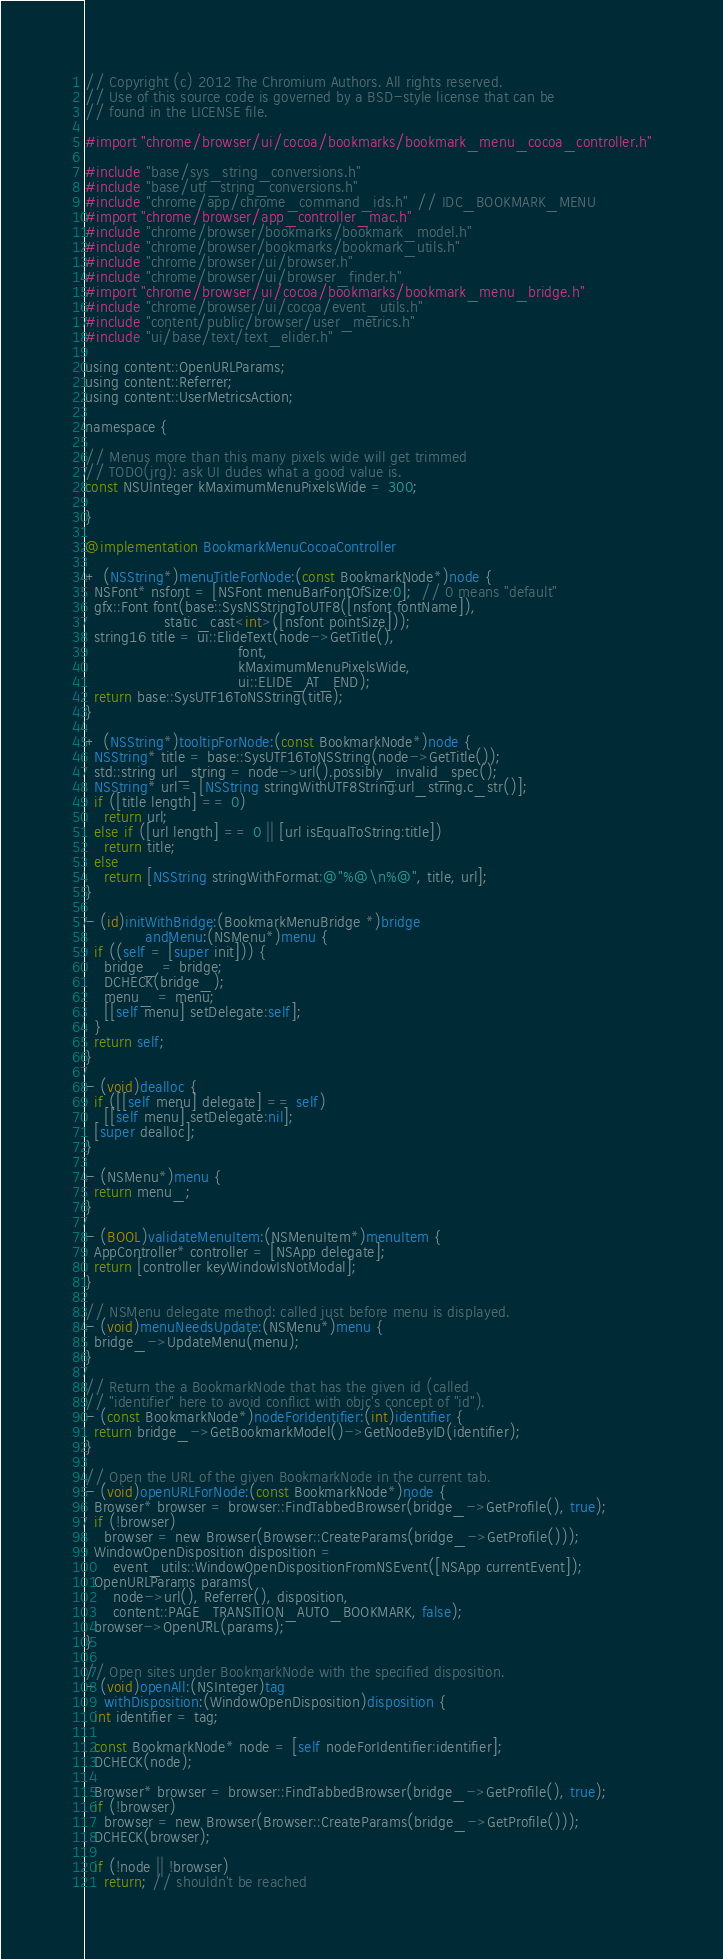<code> <loc_0><loc_0><loc_500><loc_500><_ObjectiveC_>// Copyright (c) 2012 The Chromium Authors. All rights reserved.
// Use of this source code is governed by a BSD-style license that can be
// found in the LICENSE file.

#import "chrome/browser/ui/cocoa/bookmarks/bookmark_menu_cocoa_controller.h"

#include "base/sys_string_conversions.h"
#include "base/utf_string_conversions.h"
#include "chrome/app/chrome_command_ids.h"  // IDC_BOOKMARK_MENU
#import "chrome/browser/app_controller_mac.h"
#include "chrome/browser/bookmarks/bookmark_model.h"
#include "chrome/browser/bookmarks/bookmark_utils.h"
#include "chrome/browser/ui/browser.h"
#include "chrome/browser/ui/browser_finder.h"
#import "chrome/browser/ui/cocoa/bookmarks/bookmark_menu_bridge.h"
#include "chrome/browser/ui/cocoa/event_utils.h"
#include "content/public/browser/user_metrics.h"
#include "ui/base/text/text_elider.h"

using content::OpenURLParams;
using content::Referrer;
using content::UserMetricsAction;

namespace {

// Menus more than this many pixels wide will get trimmed
// TODO(jrg): ask UI dudes what a good value is.
const NSUInteger kMaximumMenuPixelsWide = 300;

}

@implementation BookmarkMenuCocoaController

+ (NSString*)menuTitleForNode:(const BookmarkNode*)node {
  NSFont* nsfont = [NSFont menuBarFontOfSize:0];  // 0 means "default"
  gfx::Font font(base::SysNSStringToUTF8([nsfont fontName]),
                 static_cast<int>([nsfont pointSize]));
  string16 title = ui::ElideText(node->GetTitle(),
                                 font,
                                 kMaximumMenuPixelsWide,
                                 ui::ELIDE_AT_END);
  return base::SysUTF16ToNSString(title);
}

+ (NSString*)tooltipForNode:(const BookmarkNode*)node {
  NSString* title = base::SysUTF16ToNSString(node->GetTitle());
  std::string url_string = node->url().possibly_invalid_spec();
  NSString* url = [NSString stringWithUTF8String:url_string.c_str()];
  if ([title length] == 0)
    return url;
  else if ([url length] == 0 || [url isEqualToString:title])
    return title;
  else
    return [NSString stringWithFormat:@"%@\n%@", title, url];
}

- (id)initWithBridge:(BookmarkMenuBridge *)bridge
             andMenu:(NSMenu*)menu {
  if ((self = [super init])) {
    bridge_ = bridge;
    DCHECK(bridge_);
    menu_ = menu;
    [[self menu] setDelegate:self];
  }
  return self;
}

- (void)dealloc {
  if ([[self menu] delegate] == self)
    [[self menu] setDelegate:nil];
  [super dealloc];
}

- (NSMenu*)menu {
  return menu_;
}

- (BOOL)validateMenuItem:(NSMenuItem*)menuItem {
  AppController* controller = [NSApp delegate];
  return [controller keyWindowIsNotModal];
}

// NSMenu delegate method: called just before menu is displayed.
- (void)menuNeedsUpdate:(NSMenu*)menu {
  bridge_->UpdateMenu(menu);
}

// Return the a BookmarkNode that has the given id (called
// "identifier" here to avoid conflict with objc's concept of "id").
- (const BookmarkNode*)nodeForIdentifier:(int)identifier {
  return bridge_->GetBookmarkModel()->GetNodeByID(identifier);
}

// Open the URL of the given BookmarkNode in the current tab.
- (void)openURLForNode:(const BookmarkNode*)node {
  Browser* browser = browser::FindTabbedBrowser(bridge_->GetProfile(), true);
  if (!browser)
    browser = new Browser(Browser::CreateParams(bridge_->GetProfile()));
  WindowOpenDisposition disposition =
      event_utils::WindowOpenDispositionFromNSEvent([NSApp currentEvent]);
  OpenURLParams params(
      node->url(), Referrer(), disposition,
      content::PAGE_TRANSITION_AUTO_BOOKMARK, false);
  browser->OpenURL(params);
}

// Open sites under BookmarkNode with the specified disposition.
- (void)openAll:(NSInteger)tag
    withDisposition:(WindowOpenDisposition)disposition {
  int identifier = tag;

  const BookmarkNode* node = [self nodeForIdentifier:identifier];
  DCHECK(node);

  Browser* browser = browser::FindTabbedBrowser(bridge_->GetProfile(), true);
  if (!browser)
    browser = new Browser(Browser::CreateParams(bridge_->GetProfile()));
  DCHECK(browser);

  if (!node || !browser)
    return; // shouldn't be reached
</code> 